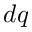Convert formula to latex. <formula><loc_0><loc_0><loc_500><loc_500>d q</formula> 